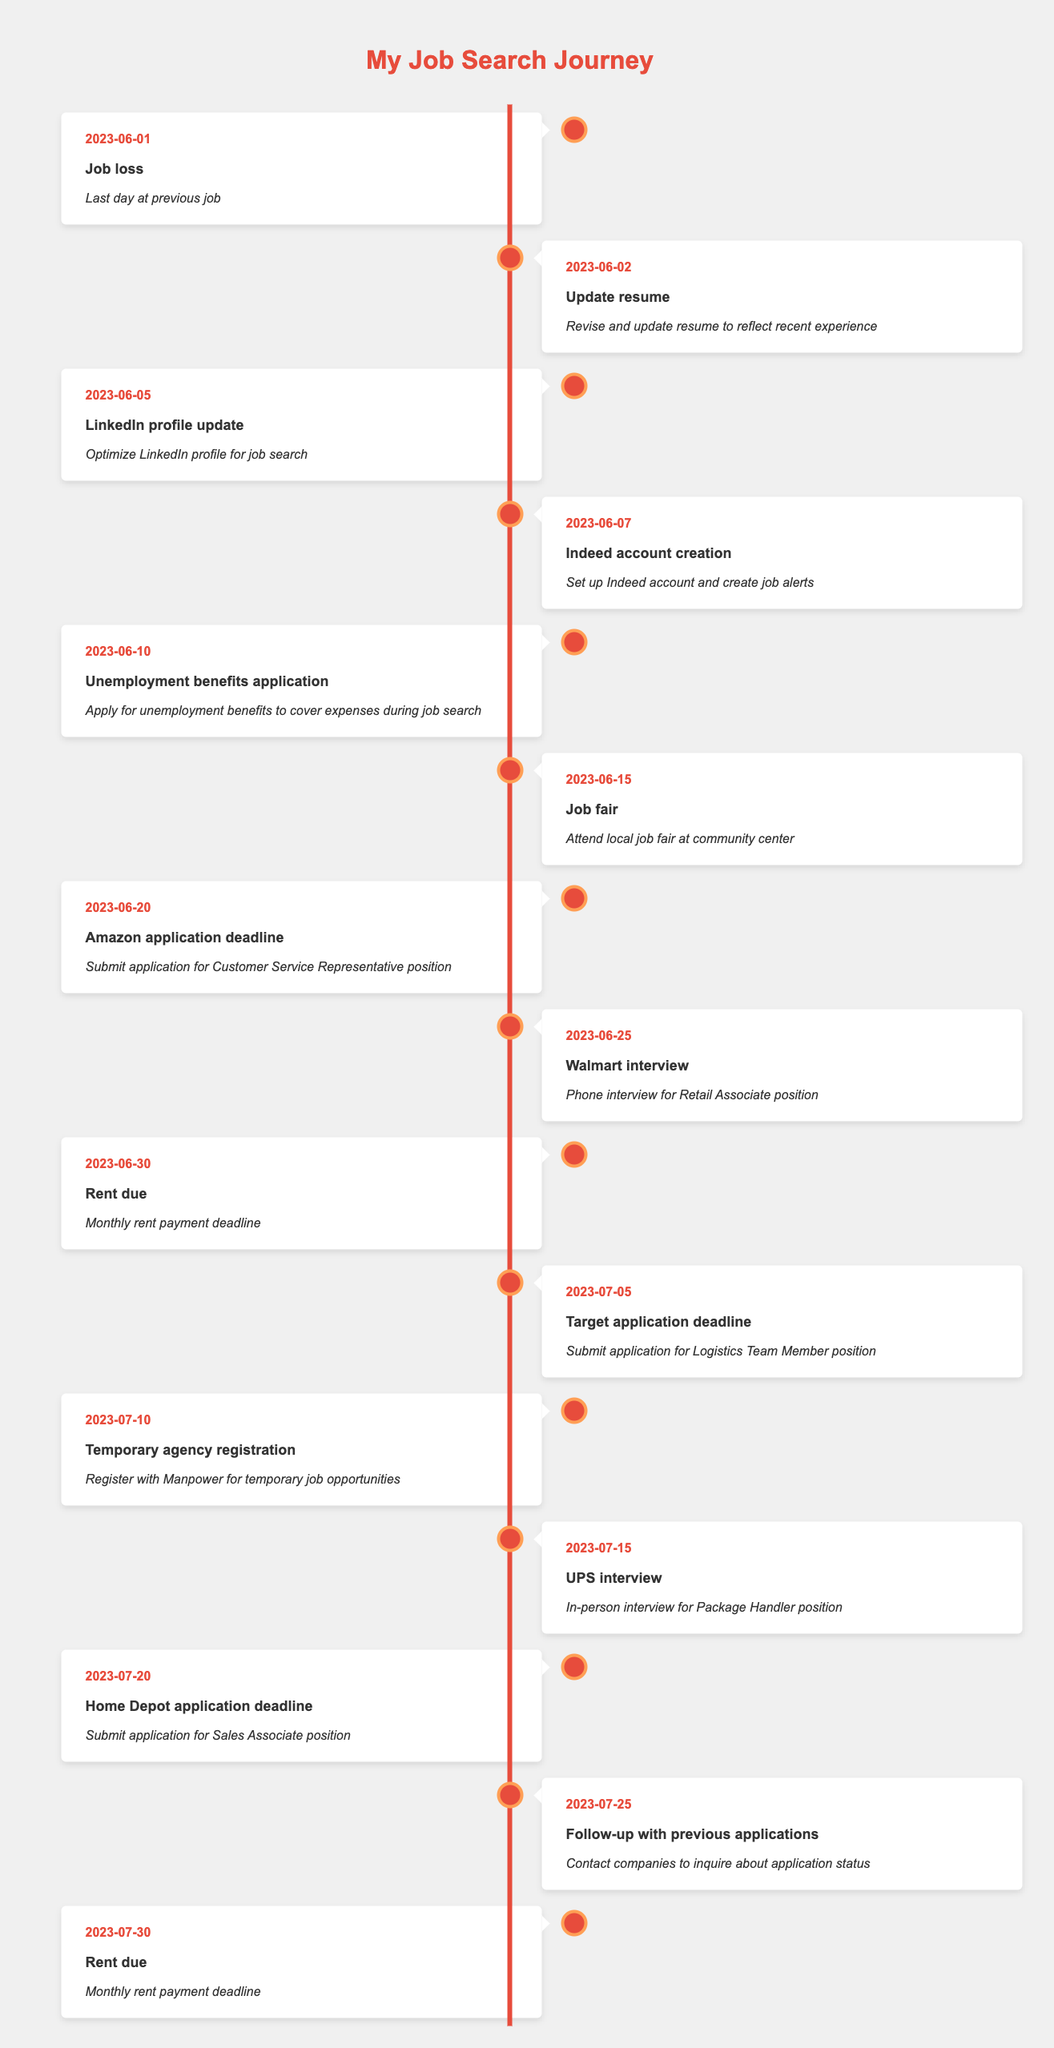What was the date of your job loss? The job loss occurred on June 1, 2023, which is directly stated in the timeline.
Answer: June 1, 2023 When should you submit the application for the Customer Service Representative position? The timeline indicates that the application deadline for this position is June 20, 2023.
Answer: June 20, 2023 How many days are there between your last day at work and the first rent payment due date? The last day at work was June 1, 2023, and the first rent due date is June 30, 2023. The difference is 29 days (30 days in June minus 1).
Answer: 29 days Did you have an interview with UPS? Yes, there is an entry in the timeline on July 15, 2023, indicating that there was an in-person interview for the Package Handler position with UPS.
Answer: Yes How many application deadlines are listed between June 10 and July 20? There are three application deadlines listed in the timeline: June 20 (Amazon), July 5 (Target), and July 20 (Home Depot), making it a total of three deadlines.
Answer: 3 What is the total number of job-related events recorded in the timeline? By counting all the events listed, there are 15 entries, which include job-related activities such as applications, interviews, and updates.
Answer: 15 On which date did you attend the local job fair? The job fair was attended on June 15, 2023, as noted in the timeline.
Answer: June 15, 2023 If you needed to contact companies regarding your application status, when should you follow up? The timeline states that the follow-up with previous applications is scheduled for July 25, 2023.
Answer: July 25, 2023 How many days are there between the job fair and the first rent payment due? The job fair took place on June 15, 2023, and the first rent payment is due on June 30, 2023. The difference is 15 days.
Answer: 15 days 